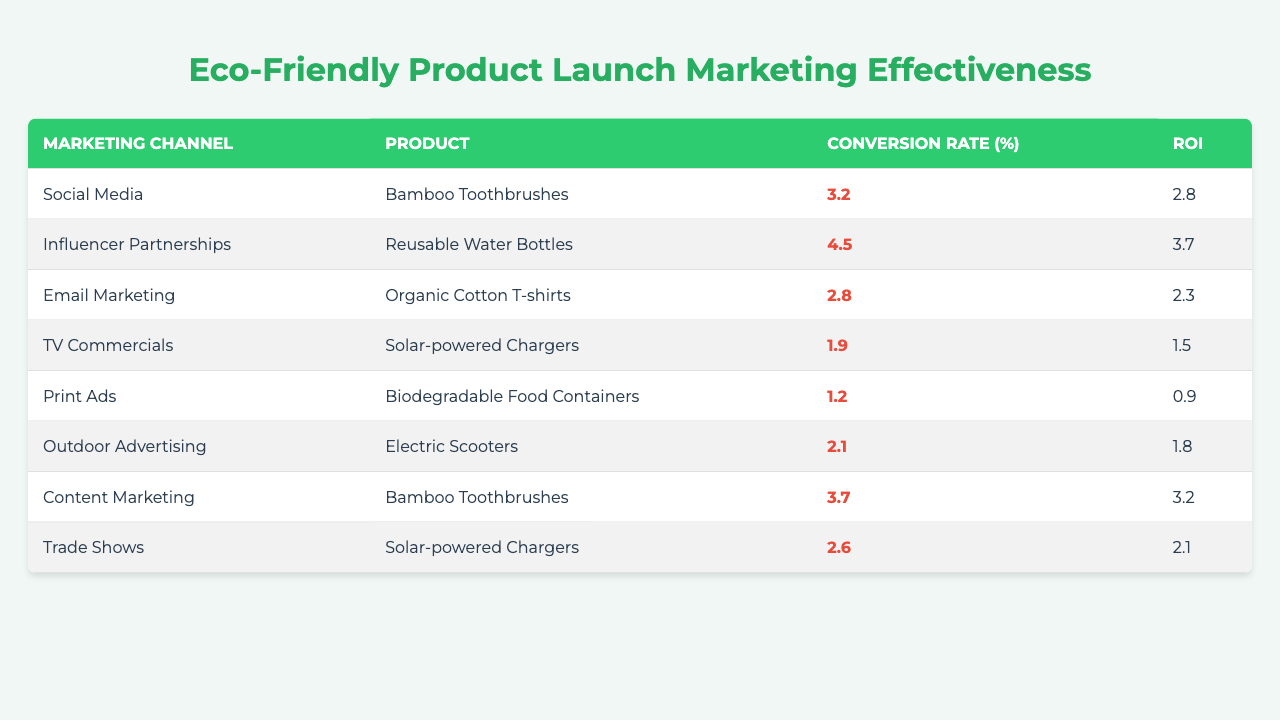What marketing channel has the highest conversion rate for eco-friendly products? By reviewing the table, we can see that "Influencer Partnerships" for "Reusable Water Bottles" has the highest conversion rate at 4.5%.
Answer: Influencer Partnerships What is the ROI for outdoor advertising for Electric Scooters? The table shows that the ROI for "Outdoor Advertising" related to "Electric Scooters" is 1.8, which we can directly observe.
Answer: 1.8 Which product has the lowest conversion rate and what is that rate? Looking through the table, "Print Ads" for "Biodegradable Food Containers" shows the lowest conversion rate at 1.2%.
Answer: 1.2% What is the average conversion rate for Social Media and Content Marketing combined? The conversion rates for Social Media (Bamboo Toothbrushes) is 3.2% and for Content Marketing (Bamboo Toothbrushes) is 3.7%. Adding these together gives 3.2 + 3.7 = 6.9, and dividing by 2 (as there are 2 channels) gives an average conversion rate of 6.9/2 = 3.45%.
Answer: 3.45% True or False: The ROI for Email Marketing is higher than that for TV Commercials. From the table, Email Marketing has an ROI of 2.3 while TV Commercials have an ROI of 1.5. Since 2.3 > 1.5, the statement is true.
Answer: True Which marketing channel resulted in the highest ROI and what was it? Reviewing the table, "Influencer Partnerships" for "Reusable Water Bottles" has the highest ROI of 3.7. This value stands out clearly when comparing all the ROI figures.
Answer: 3.7 What is the difference in conversion rates between Trade Shows and Email Marketing? Trade Shows have a conversion rate of 2.6% while Email Marketing has a conversion rate of 2.8%. The difference is calculated as 2.8 - 2.6 = 0.2%.
Answer: 0.2% Which marketing channel had a better effectiveness score, based on both conversion rate and ROI, for Solar-powered Chargers? The table shows that "TV Commercials" have a conversion rate of 1.9 and ROI of 1.5, while "Trade Shows" have a conversion rate of 2.6 and ROI of 2.1. Both metrics for Trade Shows exceed those for TV Commercials, indicating that Trade Shows are more effective.
Answer: Trade Shows What is the total ROI of all marketing efforts for Bamboo Toothbrushes? The table shows two entries for Bamboo Toothbrushes: Social Media with an ROI of 2.8 and Content Marketing with an ROI of 3.2. Thus, we calculate the total ROI as 2.8 + 3.2 = 6.0.
Answer: 6.0 Does Email Marketing show a competitive performance compared to the other channels used for eco-friendly products? Comparing the ROI of Email Marketing (2.3) to other channels such as Influencer Partnerships (3.7) and Content Marketing (3.2) indicates that while it performs adequately, it does not outperform some of the other channels, thus suggesting a less competitive edge in this instance.
Answer: No 